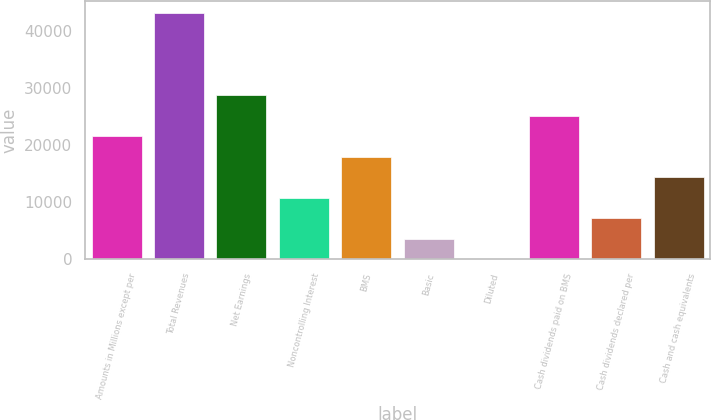Convert chart. <chart><loc_0><loc_0><loc_500><loc_500><bar_chart><fcel>Amounts in Millions except per<fcel>Total Revenues<fcel>Net Earnings<fcel>Noncontrolling Interest<fcel>BMS<fcel>Basic<fcel>Diluted<fcel>Cash dividends paid on BMS<fcel>Cash dividends declared per<fcel>Cash and cash equivalents<nl><fcel>21538.6<fcel>43076.1<fcel>28717.8<fcel>10769.9<fcel>17949.1<fcel>3590.74<fcel>1.16<fcel>25128.2<fcel>7180.32<fcel>14359.5<nl></chart> 